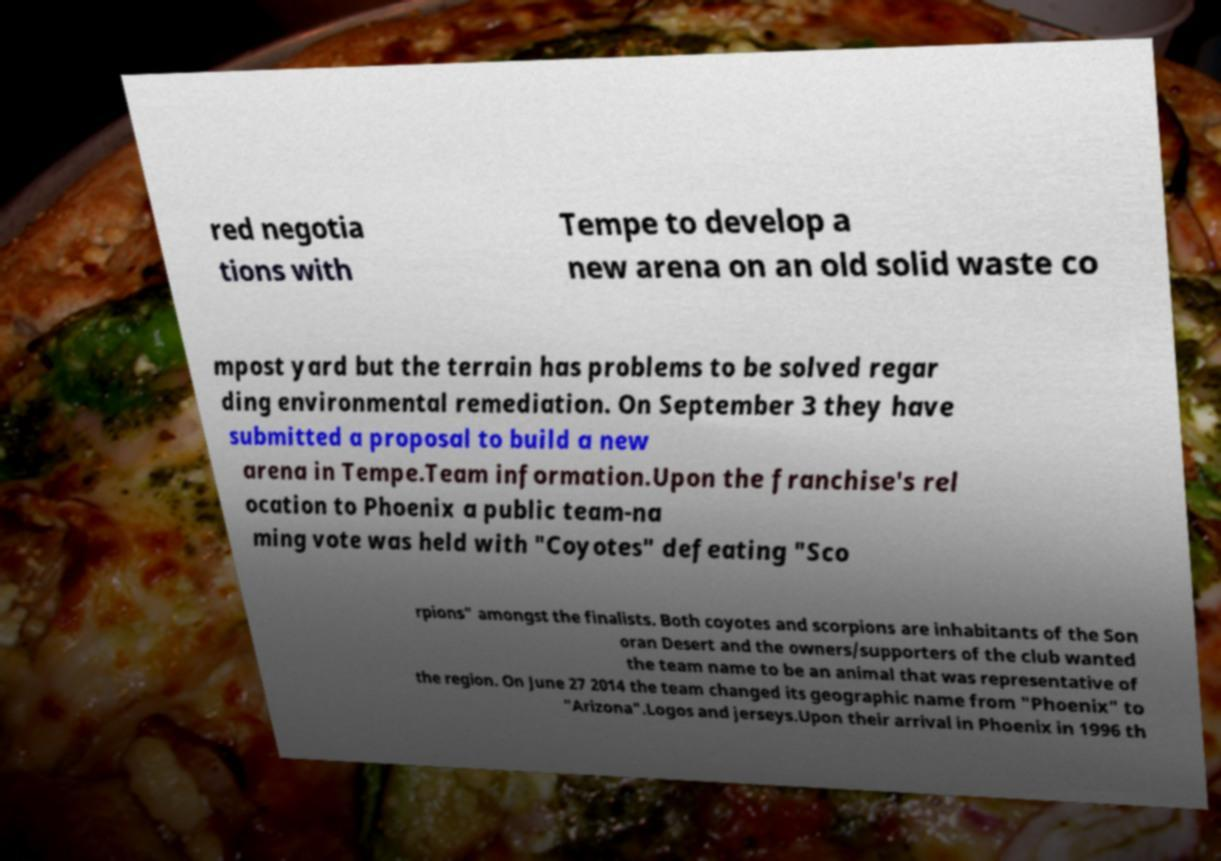I need the written content from this picture converted into text. Can you do that? red negotia tions with Tempe to develop a new arena on an old solid waste co mpost yard but the terrain has problems to be solved regar ding environmental remediation. On September 3 they have submitted a proposal to build a new arena in Tempe.Team information.Upon the franchise's rel ocation to Phoenix a public team-na ming vote was held with "Coyotes" defeating "Sco rpions" amongst the finalists. Both coyotes and scorpions are inhabitants of the Son oran Desert and the owners/supporters of the club wanted the team name to be an animal that was representative of the region. On June 27 2014 the team changed its geographic name from "Phoenix" to "Arizona".Logos and jerseys.Upon their arrival in Phoenix in 1996 th 